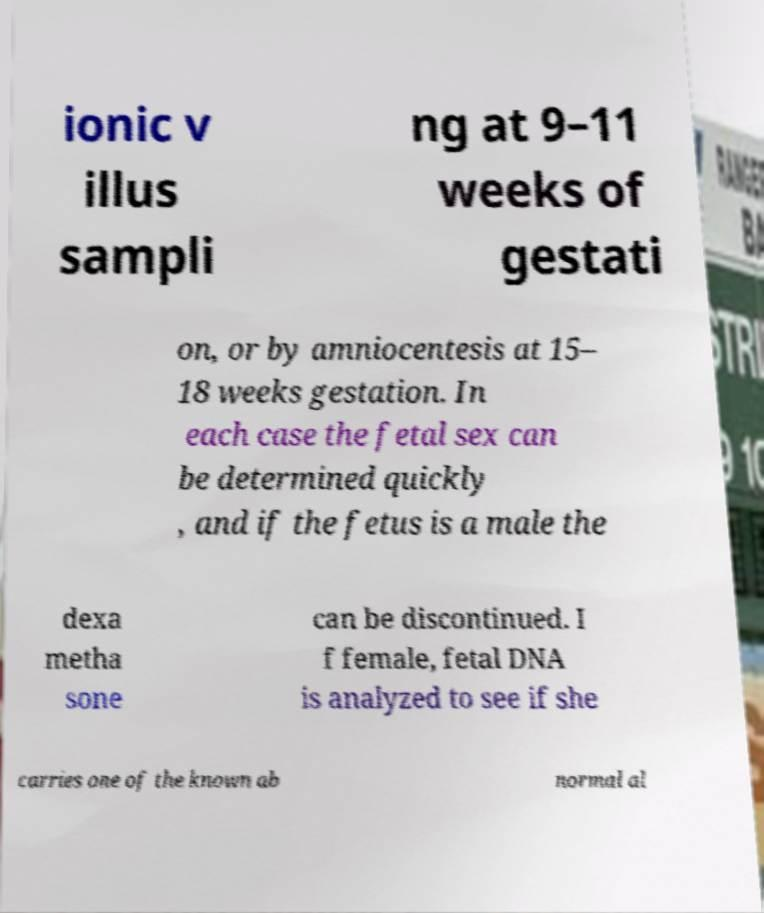What messages or text are displayed in this image? I need them in a readable, typed format. ionic v illus sampli ng at 9–11 weeks of gestati on, or by amniocentesis at 15– 18 weeks gestation. In each case the fetal sex can be determined quickly , and if the fetus is a male the dexa metha sone can be discontinued. I f female, fetal DNA is analyzed to see if she carries one of the known ab normal al 